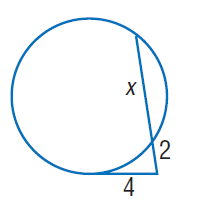Question: Find x. Round to the nearest tenth if necessary. Assume that segments that appear to be tangent are tangent.
Choices:
A. 2
B. 4
C. 6
D. 8
Answer with the letter. Answer: C 